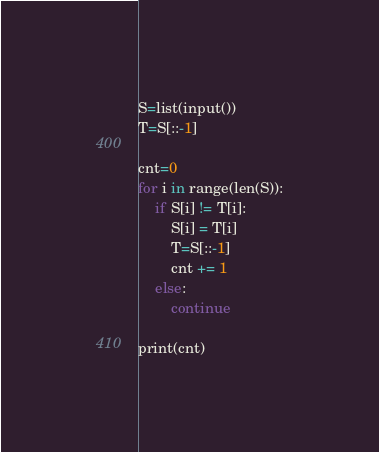<code> <loc_0><loc_0><loc_500><loc_500><_Python_>S=list(input())
T=S[::-1]

cnt=0
for i in range(len(S)):
    if S[i] != T[i]:
        S[i] = T[i]
        T=S[::-1]
        cnt += 1
    else:
        continue

print(cnt)</code> 